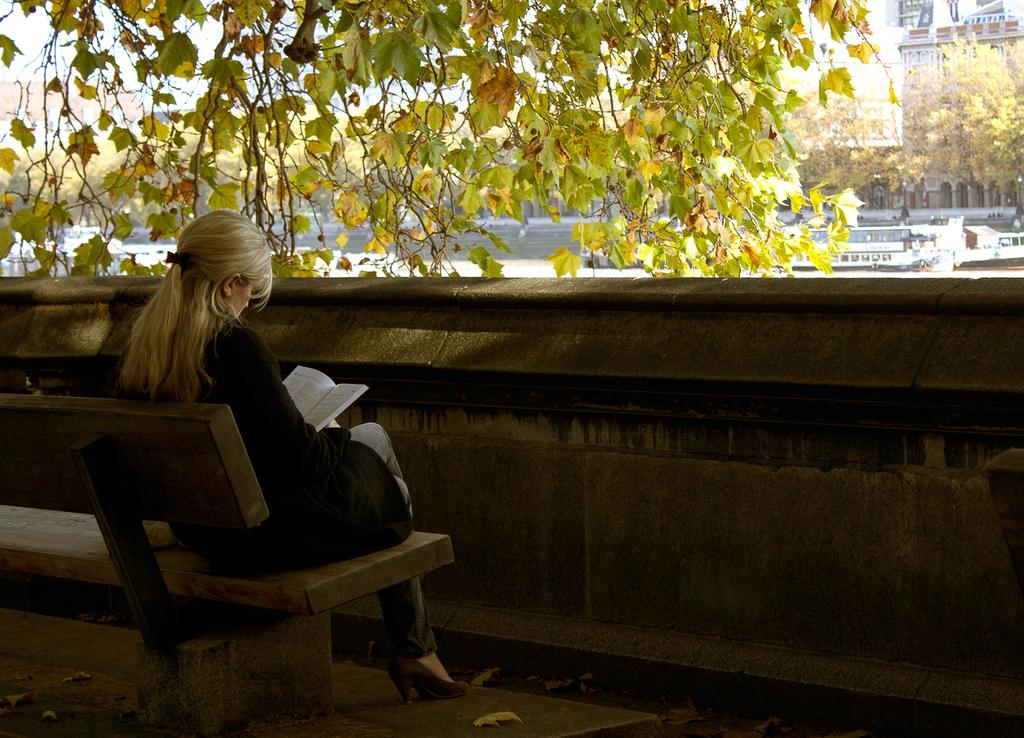Who is the main subject in the image? There is a woman in the image. What is the woman doing in the image? The woman is reading a book. What type of furniture is present in the image? There is a bench in the image. What architectural feature can be seen in the background? There is a barrier wall in the image. What type of card is the woman holding in the image? There is no card present in the image; the woman is reading a book. What is the woman's temper like in the image? The image does not provide any information about the woman's temper. 